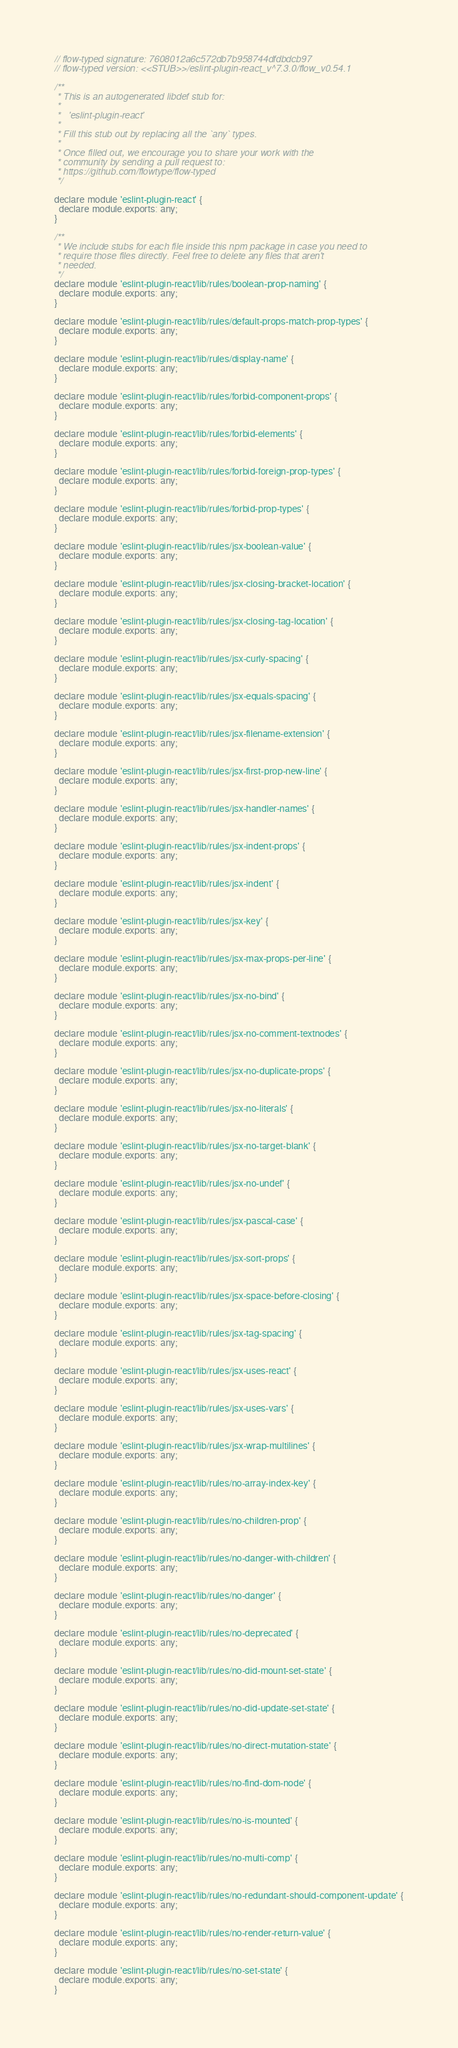<code> <loc_0><loc_0><loc_500><loc_500><_JavaScript_>// flow-typed signature: 7608012a6c572db7b958744dfdbdcb97
// flow-typed version: <<STUB>>/eslint-plugin-react_v^7.3.0/flow_v0.54.1

/**
 * This is an autogenerated libdef stub for:
 *
 *   'eslint-plugin-react'
 *
 * Fill this stub out by replacing all the `any` types.
 *
 * Once filled out, we encourage you to share your work with the
 * community by sending a pull request to:
 * https://github.com/flowtype/flow-typed
 */

declare module 'eslint-plugin-react' {
  declare module.exports: any;
}

/**
 * We include stubs for each file inside this npm package in case you need to
 * require those files directly. Feel free to delete any files that aren't
 * needed.
 */
declare module 'eslint-plugin-react/lib/rules/boolean-prop-naming' {
  declare module.exports: any;
}

declare module 'eslint-plugin-react/lib/rules/default-props-match-prop-types' {
  declare module.exports: any;
}

declare module 'eslint-plugin-react/lib/rules/display-name' {
  declare module.exports: any;
}

declare module 'eslint-plugin-react/lib/rules/forbid-component-props' {
  declare module.exports: any;
}

declare module 'eslint-plugin-react/lib/rules/forbid-elements' {
  declare module.exports: any;
}

declare module 'eslint-plugin-react/lib/rules/forbid-foreign-prop-types' {
  declare module.exports: any;
}

declare module 'eslint-plugin-react/lib/rules/forbid-prop-types' {
  declare module.exports: any;
}

declare module 'eslint-plugin-react/lib/rules/jsx-boolean-value' {
  declare module.exports: any;
}

declare module 'eslint-plugin-react/lib/rules/jsx-closing-bracket-location' {
  declare module.exports: any;
}

declare module 'eslint-plugin-react/lib/rules/jsx-closing-tag-location' {
  declare module.exports: any;
}

declare module 'eslint-plugin-react/lib/rules/jsx-curly-spacing' {
  declare module.exports: any;
}

declare module 'eslint-plugin-react/lib/rules/jsx-equals-spacing' {
  declare module.exports: any;
}

declare module 'eslint-plugin-react/lib/rules/jsx-filename-extension' {
  declare module.exports: any;
}

declare module 'eslint-plugin-react/lib/rules/jsx-first-prop-new-line' {
  declare module.exports: any;
}

declare module 'eslint-plugin-react/lib/rules/jsx-handler-names' {
  declare module.exports: any;
}

declare module 'eslint-plugin-react/lib/rules/jsx-indent-props' {
  declare module.exports: any;
}

declare module 'eslint-plugin-react/lib/rules/jsx-indent' {
  declare module.exports: any;
}

declare module 'eslint-plugin-react/lib/rules/jsx-key' {
  declare module.exports: any;
}

declare module 'eslint-plugin-react/lib/rules/jsx-max-props-per-line' {
  declare module.exports: any;
}

declare module 'eslint-plugin-react/lib/rules/jsx-no-bind' {
  declare module.exports: any;
}

declare module 'eslint-plugin-react/lib/rules/jsx-no-comment-textnodes' {
  declare module.exports: any;
}

declare module 'eslint-plugin-react/lib/rules/jsx-no-duplicate-props' {
  declare module.exports: any;
}

declare module 'eslint-plugin-react/lib/rules/jsx-no-literals' {
  declare module.exports: any;
}

declare module 'eslint-plugin-react/lib/rules/jsx-no-target-blank' {
  declare module.exports: any;
}

declare module 'eslint-plugin-react/lib/rules/jsx-no-undef' {
  declare module.exports: any;
}

declare module 'eslint-plugin-react/lib/rules/jsx-pascal-case' {
  declare module.exports: any;
}

declare module 'eslint-plugin-react/lib/rules/jsx-sort-props' {
  declare module.exports: any;
}

declare module 'eslint-plugin-react/lib/rules/jsx-space-before-closing' {
  declare module.exports: any;
}

declare module 'eslint-plugin-react/lib/rules/jsx-tag-spacing' {
  declare module.exports: any;
}

declare module 'eslint-plugin-react/lib/rules/jsx-uses-react' {
  declare module.exports: any;
}

declare module 'eslint-plugin-react/lib/rules/jsx-uses-vars' {
  declare module.exports: any;
}

declare module 'eslint-plugin-react/lib/rules/jsx-wrap-multilines' {
  declare module.exports: any;
}

declare module 'eslint-plugin-react/lib/rules/no-array-index-key' {
  declare module.exports: any;
}

declare module 'eslint-plugin-react/lib/rules/no-children-prop' {
  declare module.exports: any;
}

declare module 'eslint-plugin-react/lib/rules/no-danger-with-children' {
  declare module.exports: any;
}

declare module 'eslint-plugin-react/lib/rules/no-danger' {
  declare module.exports: any;
}

declare module 'eslint-plugin-react/lib/rules/no-deprecated' {
  declare module.exports: any;
}

declare module 'eslint-plugin-react/lib/rules/no-did-mount-set-state' {
  declare module.exports: any;
}

declare module 'eslint-plugin-react/lib/rules/no-did-update-set-state' {
  declare module.exports: any;
}

declare module 'eslint-plugin-react/lib/rules/no-direct-mutation-state' {
  declare module.exports: any;
}

declare module 'eslint-plugin-react/lib/rules/no-find-dom-node' {
  declare module.exports: any;
}

declare module 'eslint-plugin-react/lib/rules/no-is-mounted' {
  declare module.exports: any;
}

declare module 'eslint-plugin-react/lib/rules/no-multi-comp' {
  declare module.exports: any;
}

declare module 'eslint-plugin-react/lib/rules/no-redundant-should-component-update' {
  declare module.exports: any;
}

declare module 'eslint-plugin-react/lib/rules/no-render-return-value' {
  declare module.exports: any;
}

declare module 'eslint-plugin-react/lib/rules/no-set-state' {
  declare module.exports: any;
}
</code> 